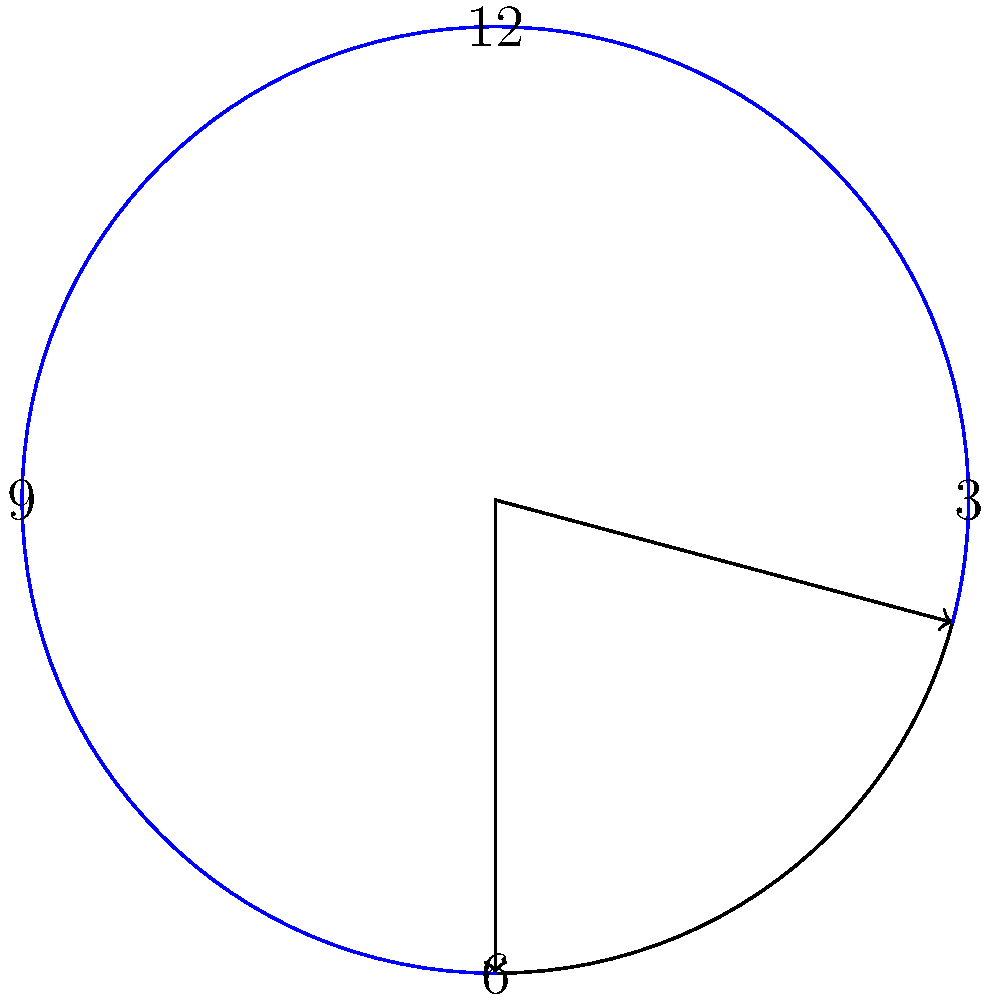In the context of divine timing, consider a clock showing 3:30. What is the measure of the acute angle formed between the hour and minute hands, and how might this relate to the concept of kairos in theological studies? To solve this problem, let's approach it step-by-step:

1) First, we need to calculate the positions of the hour and minute hands:
   - The hour hand moves 30° every hour and an additional 0.5° every minute.
   - The minute hand moves 6° every minute.

2) At 3:30:
   - The hour hand has moved from 3 o'clock: 30 * 0.5° = 15°
   - So the hour hand is at 90° + 15° = 105° from the 12 o'clock position
   - The minute hand is at 30 * 6° = 180° from the 12 o'clock position

3) The acute angle between the hands is the smaller of the two angles formed:
   $180° - 105° = 75°$

4) In theological studies, kairos refers to the "right time" or "God's time" as opposed to chronos, which is chronological time. The angle formed at 3:30 could be seen as a representation of kairos:
   - The number 3 in Christianity often represents the Trinity.
   - 30 minutes past the hour could symbolize completion or fulfillment (as in Christ's age when he began his ministry).
   - The 75° angle formed might be interpreted as 3/4 of a right angle (90°), suggesting a moment approaching divine perfection or completion.

5) This intersection of chronological time (the clock face) and divine significance (the numbers and angles) illustrates how kairos can be perceived within the framework of chronos, a key concept in theological understanding of time and God's plan.
Answer: 75° 